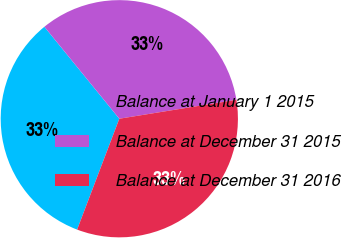<chart> <loc_0><loc_0><loc_500><loc_500><pie_chart><fcel>Balance at January 1 2015<fcel>Balance at December 31 2015<fcel>Balance at December 31 2016<nl><fcel>33.33%<fcel>33.33%<fcel>33.34%<nl></chart> 